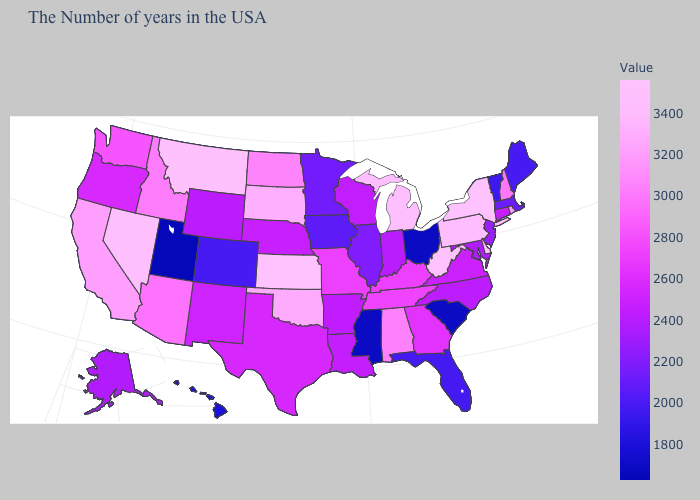Does Utah have the lowest value in the USA?
Give a very brief answer. Yes. Which states hav the highest value in the Northeast?
Concise answer only. New York. Among the states that border Virginia , does Maryland have the lowest value?
Quick response, please. Yes. Does Indiana have the highest value in the USA?
Write a very short answer. No. 